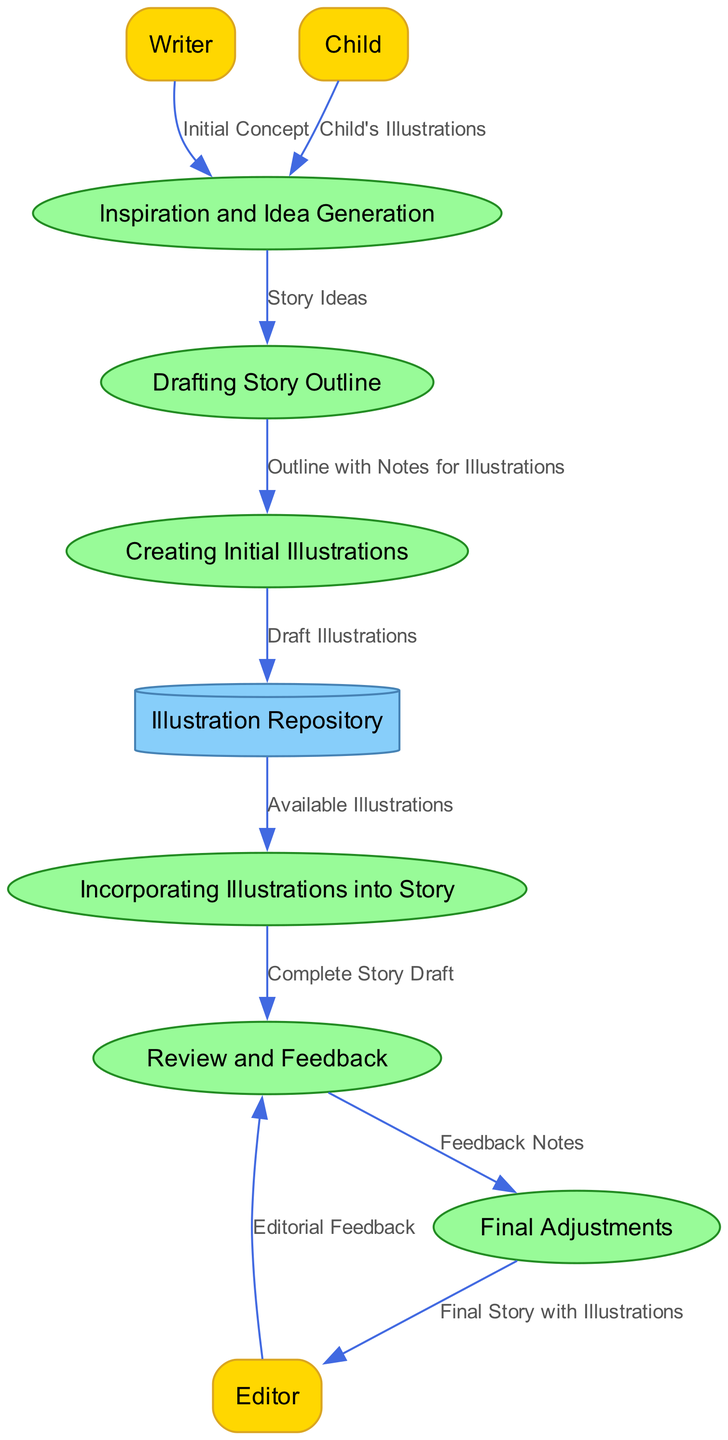What are the external entities in the diagram? The external entities listed in the diagram include 'Writer', 'Child', and 'Editor'. These are visualized as separate rectangles in the diagram.
Answer: Writer, Child, Editor How many processes are represented in the diagram? There are six processes shown in the diagram, each represented as an ellipse. The processes include 'Inspiration and Idea Generation', 'Drafting Story Outline', 'Creating Initial Illustrations', 'Incorporating Illustrations into Story', 'Review and Feedback', and 'Final Adjustments'.
Answer: 6 What data flows from 'Creating Initial Illustrations' to 'Illustration Repository'? The data flow from 'Creating Initial Illustrations' to 'Illustration Repository' is labeled 'Draft Illustrations'. This indicates that the draft illustrations are stored in the repository.
Answer: Draft Illustrations What is the purpose of the process 'Review and Feedback'? The process 'Review and Feedback' is aimed at receiving external 'Editorial Feedback' from the Editor, analyzing it, and preparing for 'Final Adjustments'. It plays a critical role in the final stages of the illustration creation process.
Answer: To analyze feedback Which process has data flowing into it from the 'Drafting Story Outline'? The process that receives data from 'Drafting Story Outline' is 'Creating Initial Illustrations'. This means that the outline along with notes for illustrations is used to create the initial visuals for the story.
Answer: Creating Initial Illustrations What is the final output of the process 'Final Adjustments'? The final output of the process 'Final Adjustments' is the 'Final Story with Illustrations', which is then sent to the Editor. This step signifies the completion of the illustration process in story development.
Answer: Final Story with Illustrations What role does the 'Child' play in the diagram? The 'Child' contributes 'Child's Illustrations' to the 'Inspiration and Idea Generation' process, which helps to inspire and inform the writer's concept for the story. This input is vital as it reflects the creative influence from the child.
Answer: Contributes illustrations In how many different ways does feedback enter the review process? Feedback enters the 'Review and Feedback' process in one way; specifically, it receives 'Editorial Feedback' from the Editor. This straightforward input highlights the linear flow of information crucial for refinement.
Answer: 1 What comes after 'Incorporating Illustrations into Story'? The next process after 'Incorporating Illustrations into Story' is 'Review and Feedback', which signifies that once the illustrations are integrated, the complete draft is reviewed for further feedback.
Answer: Review and Feedback 